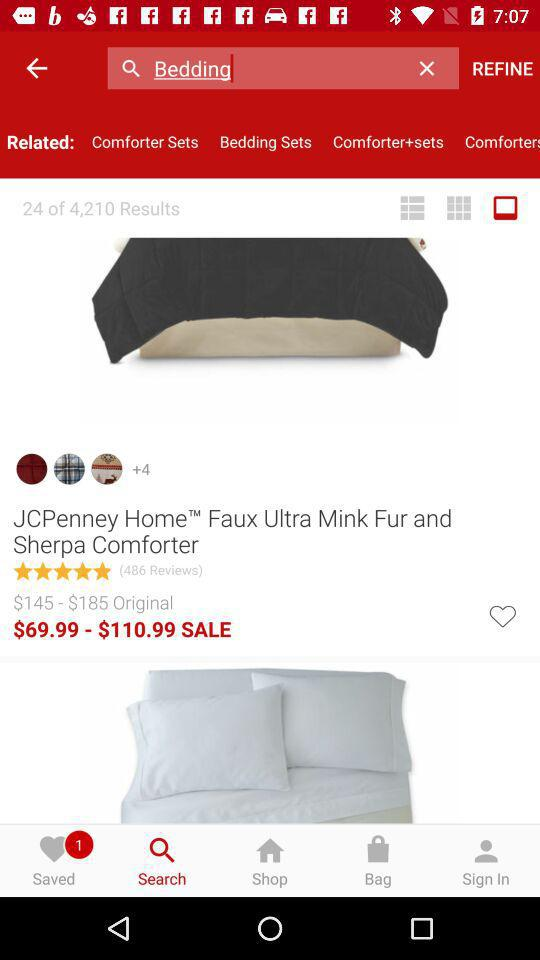What is the entered term? The entered term is "Bedding". 